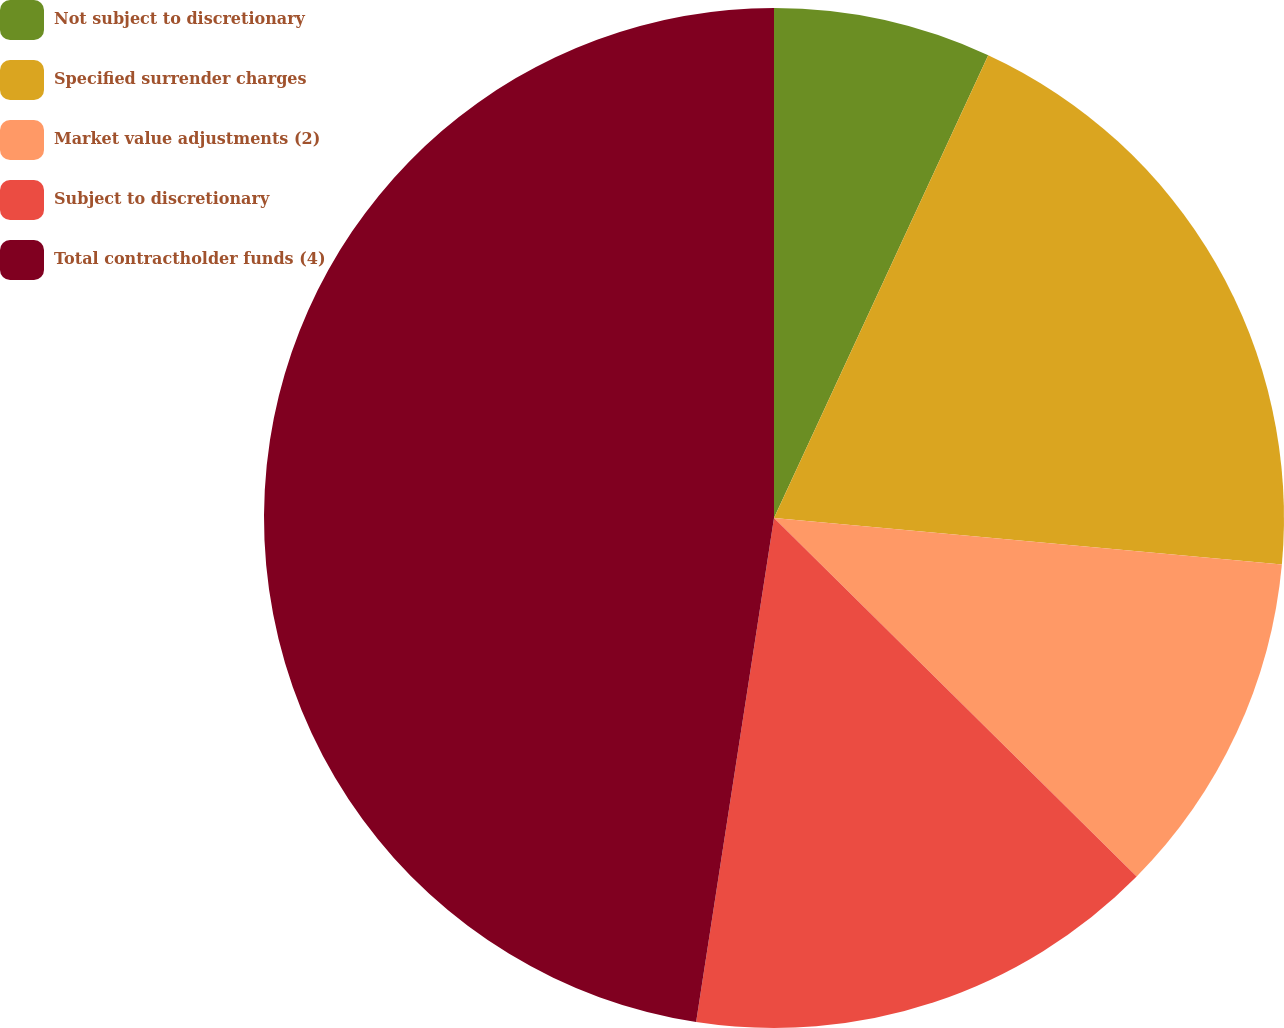Convert chart. <chart><loc_0><loc_0><loc_500><loc_500><pie_chart><fcel>Not subject to discretionary<fcel>Specified surrender charges<fcel>Market value adjustments (2)<fcel>Subject to discretionary<fcel>Total contractholder funds (4)<nl><fcel>6.9%<fcel>19.55%<fcel>10.96%<fcel>15.03%<fcel>47.56%<nl></chart> 